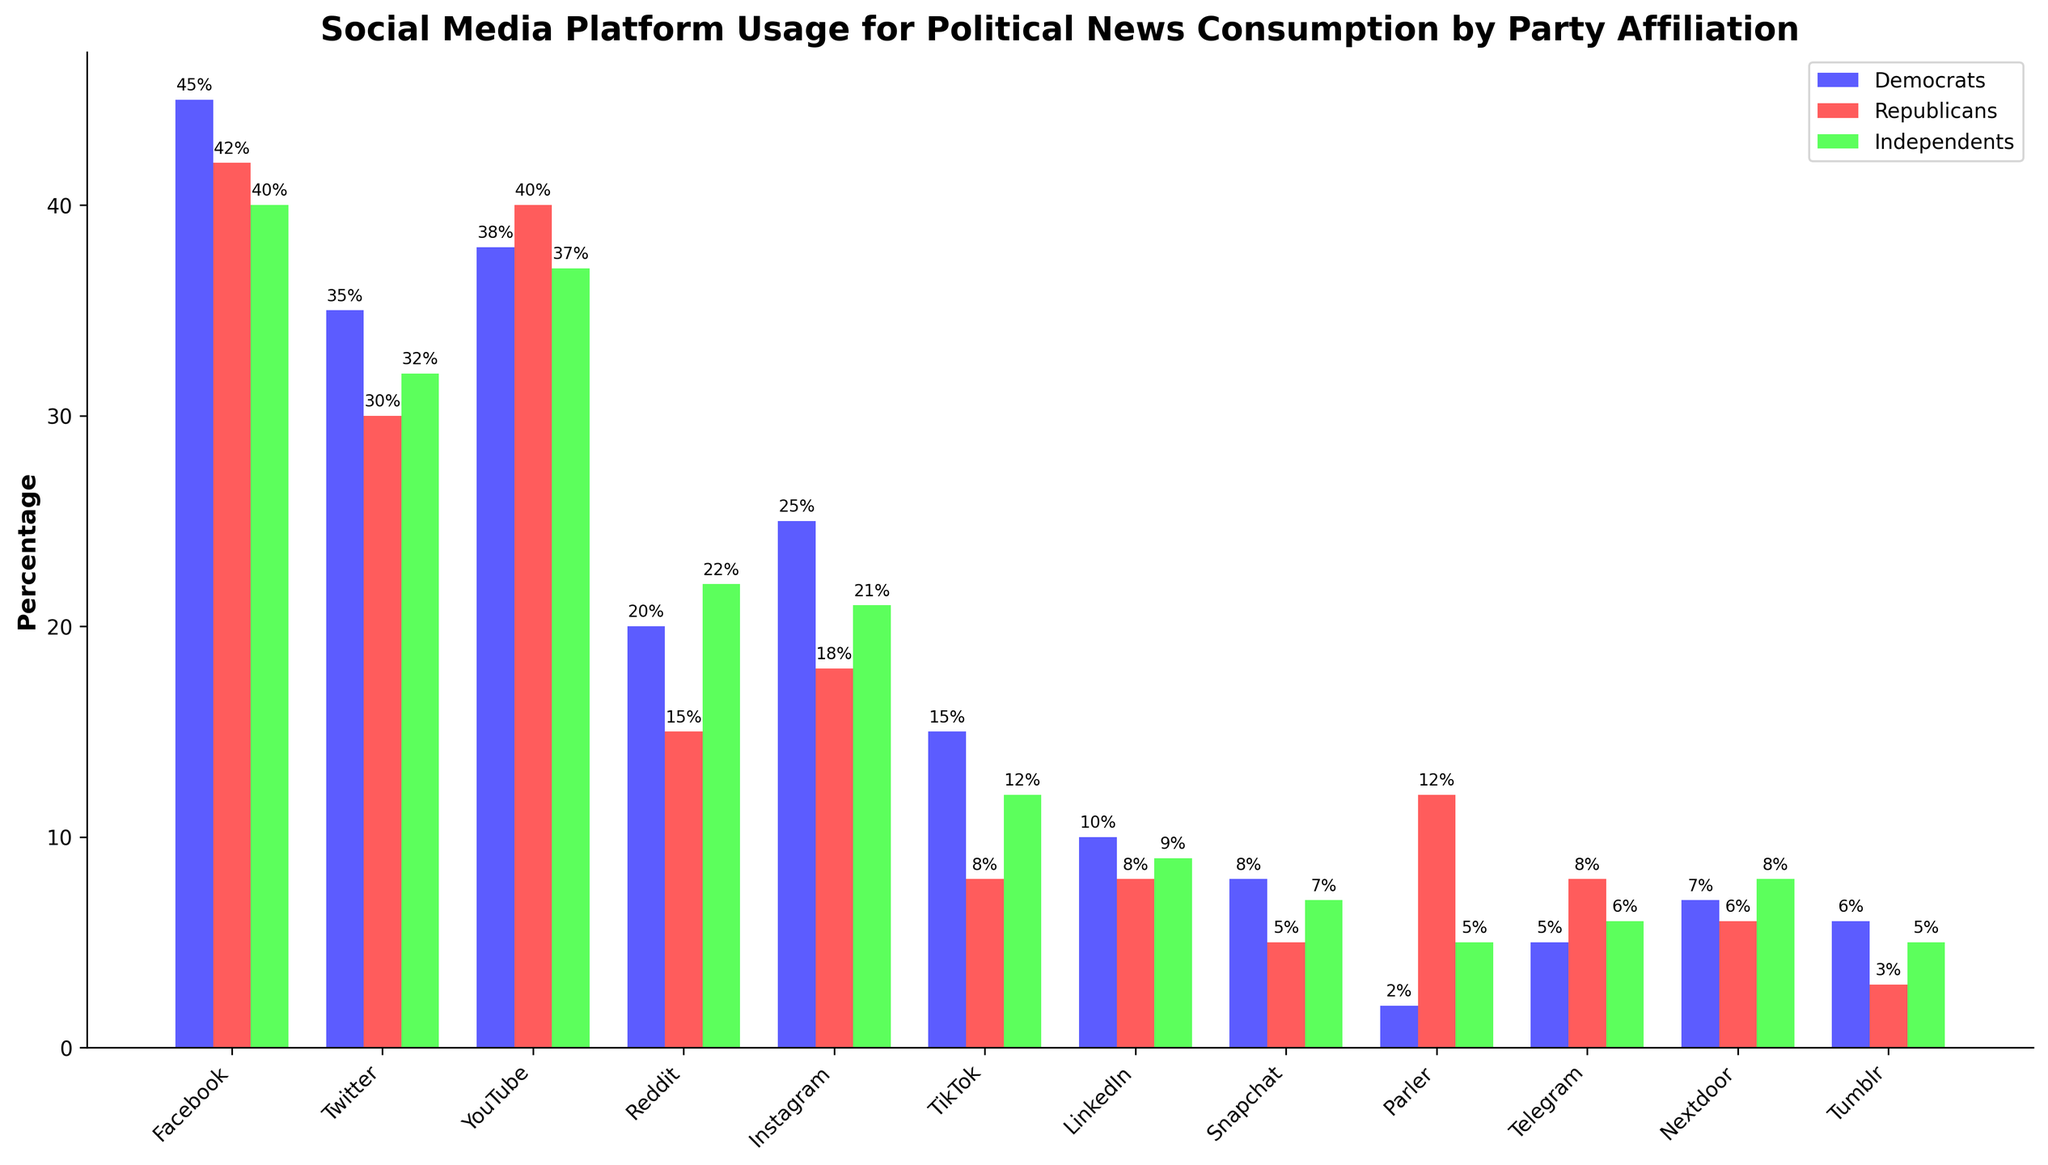What's the most used social media platform for political news among Democrats? Look at the bar heights for Democrats across all platforms. The tallest bar corresponds to Facebook.
Answer: Facebook Which social media platform has the least usage among Republicans? Look at the smallest bar corresponding to Republicans. The smallest bar corresponds to Parler.
Answer: Parler By how much does the usage percentage of Twitter differ between Democrats and Republicans? Find the height of the Twitter bar for both parties: Democrats (35%) and Republicans (30%). Subtract the smaller value from the larger value: 35% - 30% = 5%.
Answer: 5% Compare the usage percentages of Reddit among Independents and Republicans. Observe the bar heights for Reddit under Independents (22%) and Republicans (15%). Independents have a higher usage percentage.
Answer: Independents have a higher usage percentage What are the total percentages of social media platform usage for Independents across Facebook and YouTube? Add the height of the Facebook bar (40%) and the YouTube bar (37%) for Independents: 40% + 37% = 77%.
Answer: 77% Which group has a higher usage percentage for Instagram, Democrats or Republicans? Compare the heights of the Instagram bars: Democrats (25%) and Republicans (18%). Democrats have a higher percentage.
Answer: Democrats Calculate the average usage percentage of LinkedIn across all party affiliations. Sum the LinkedIn percentages for Democrats (10%), Republicans (8%), and Independents (9%), then divide by 3: (10% + 8% + 9%) / 3 = 9%.
Answer: 9% Is there a platform where Independents have the highest percentage usage compared to Democrats and Republicans? Compare the bar heights for Independents across all platforms with those for Democrats and Republicans. Reddit (22%) and Parler (5%) usage by Independents surpasses usage by both other groups.
Answer: Reddit and Parler Which group uses Telegram more, and by how much compared to the other groups? Compare the Telegram bar heights for all groups: Republicans (8%), Independents (6%), and Democrats (5%). Republicans use Telegram the most. Calculate the differences: 8% - 6% = 2% and 8% - 5% = 3%.
Answer: Republicans by 2% over Independents and 3% over Democrats 